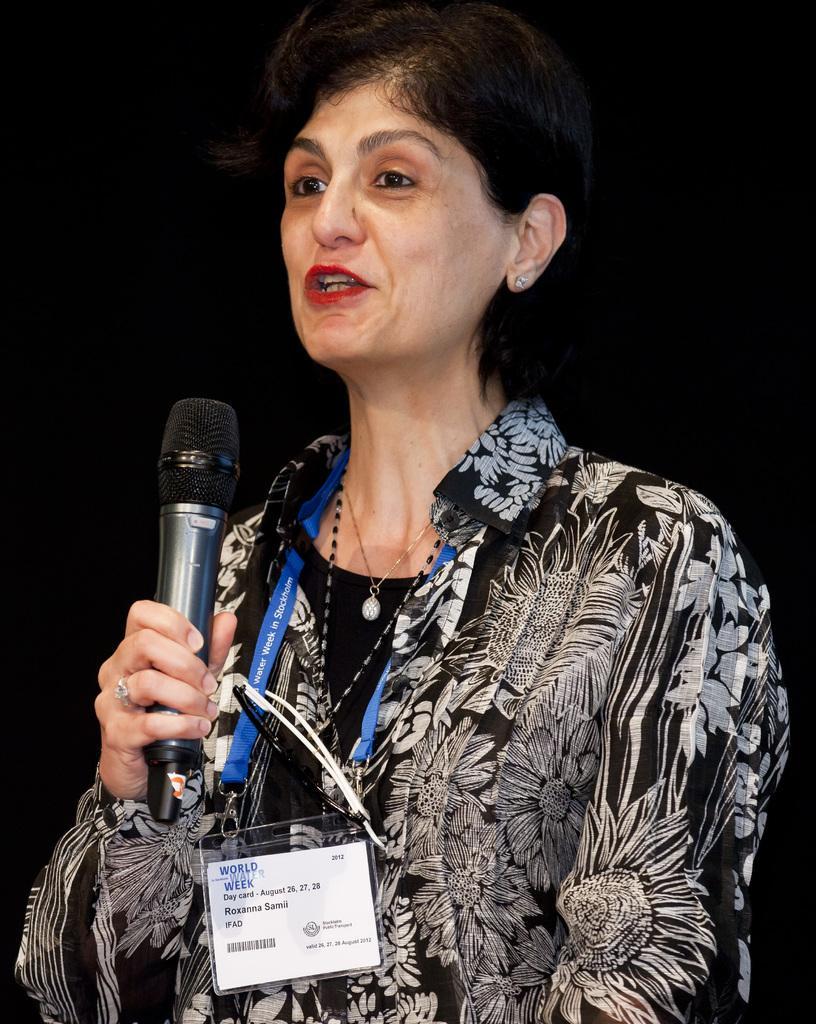Who is the main subject in the image? There is a woman in the image. What is the woman wearing? The woman is wearing a black shirt with a white design. Can you describe any accessories the woman is wearing? The woman is wearing a badge with a blue tag. What is the woman holding in the image? The woman is holding a microphone. What is the woman doing in the image? The woman is talking. What type of mist can be seen surrounding the woman in the image? There is no mist present in the image; it is a clear scene with the woman talking. 